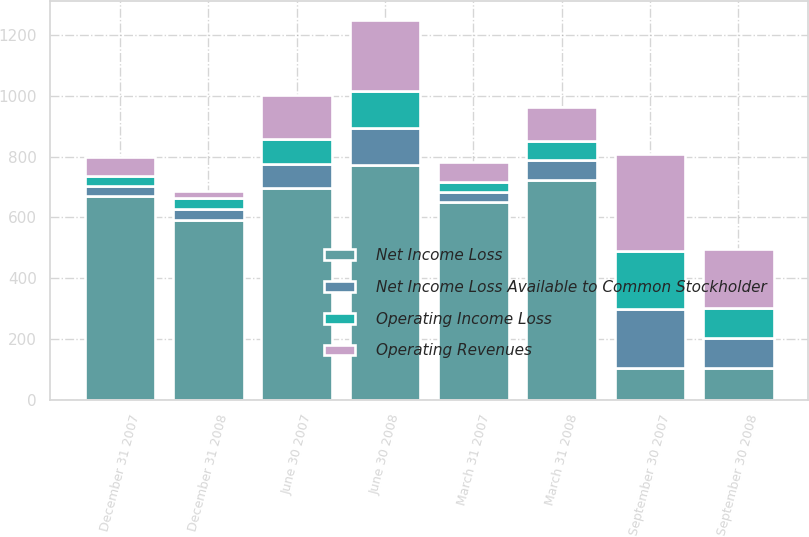Convert chart to OTSL. <chart><loc_0><loc_0><loc_500><loc_500><stacked_bar_chart><ecel><fcel>March 31 2008<fcel>March 31 2007<fcel>June 30 2008<fcel>June 30 2007<fcel>September 30 2008<fcel>September 30 2007<fcel>December 31 2008<fcel>December 31 2007<nl><fcel>Net Income Loss<fcel>724<fcel>650<fcel>771<fcel>697<fcel>105<fcel>105<fcel>590<fcel>669<nl><fcel>Operating Revenues<fcel>111<fcel>68<fcel>232<fcel>144<fcel>195<fcel>317<fcel>24<fcel>61<nl><fcel>Operating Income Loss<fcel>64<fcel>33<fcel>124<fcel>81<fcel>99<fcel>193<fcel>36<fcel>35<nl><fcel>Net Income Loss Available to Common Stockholder<fcel>63<fcel>32<fcel>122<fcel>79<fcel>98<fcel>192<fcel>38<fcel>33<nl></chart> 